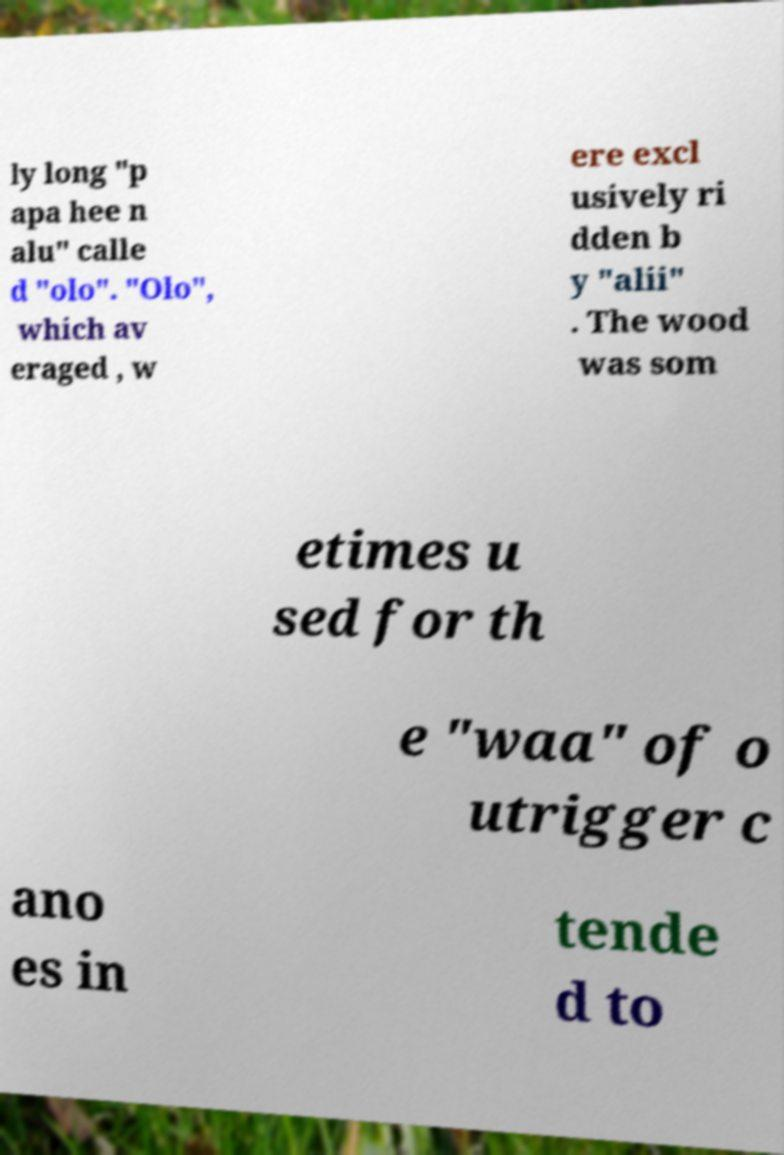Please identify and transcribe the text found in this image. ly long "p apa hee n alu" calle d "olo". "Olo", which av eraged , w ere excl usively ri dden b y "alii" . The wood was som etimes u sed for th e "waa" of o utrigger c ano es in tende d to 